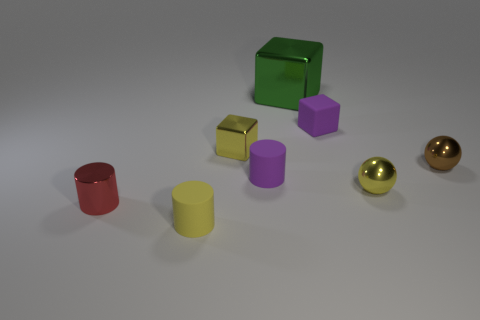Add 1 big red metallic balls. How many objects exist? 9 Subtract all spheres. How many objects are left? 6 Subtract 0 blue blocks. How many objects are left? 8 Subtract all tiny yellow spheres. Subtract all small yellow cylinders. How many objects are left? 6 Add 2 tiny yellow shiny spheres. How many tiny yellow shiny spheres are left? 3 Add 5 small brown objects. How many small brown objects exist? 6 